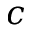Convert formula to latex. <formula><loc_0><loc_0><loc_500><loc_500>c</formula> 